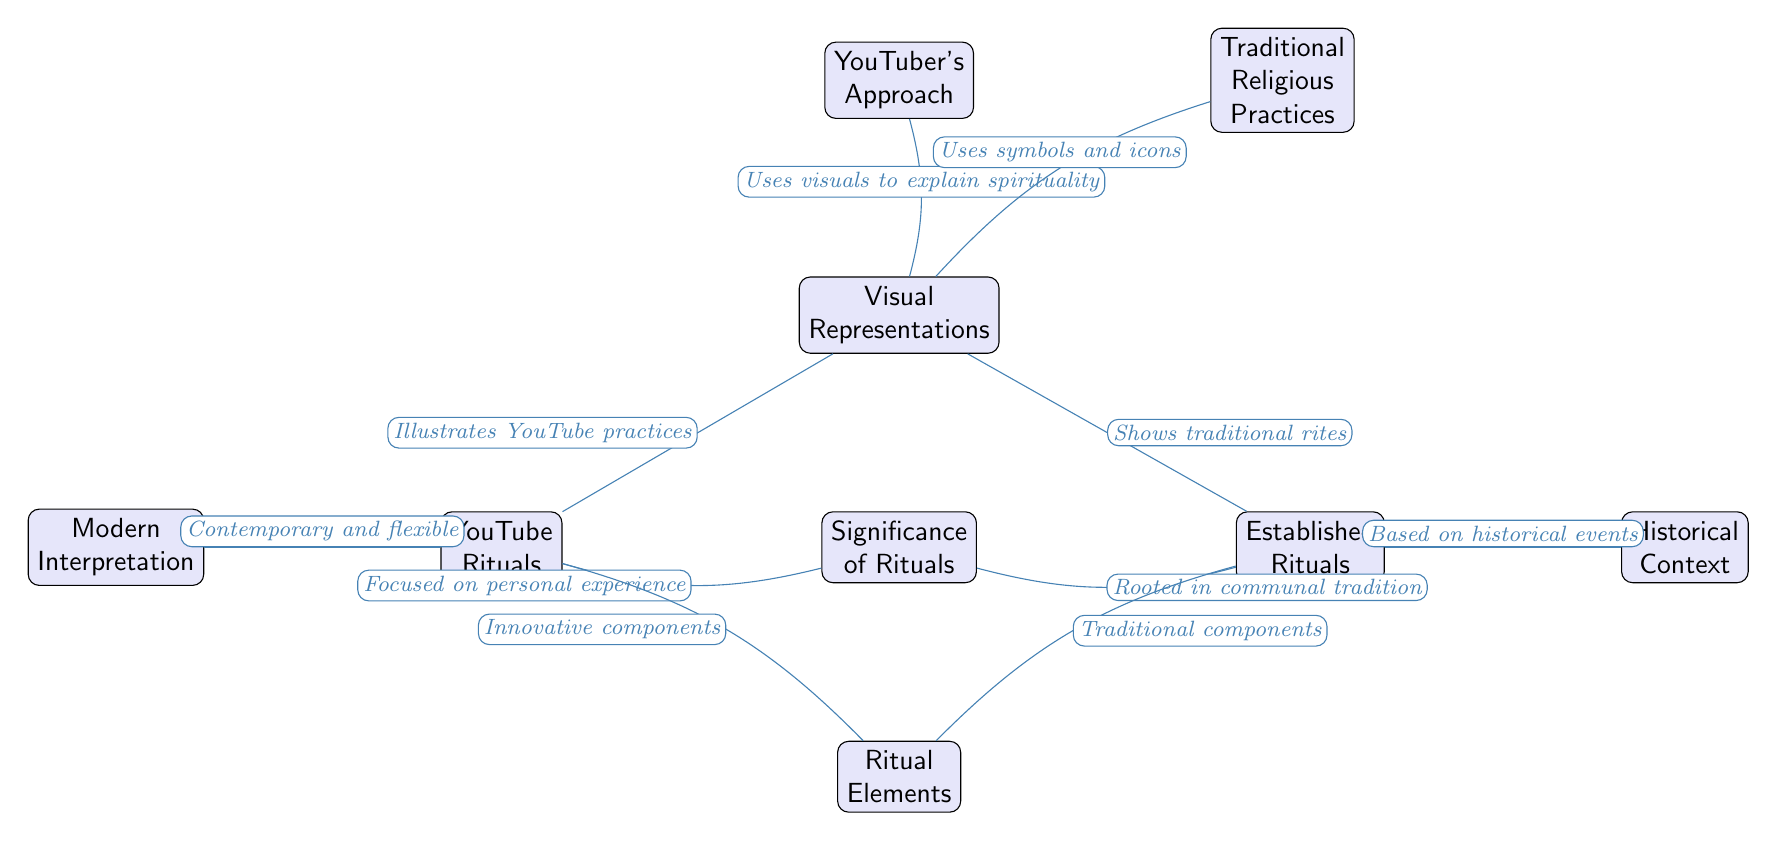what is the primary focus of the YouTuber's approach? The diagram shows that the YouTuber's approach is primarily focused on personal experience, as indicated by the arrow from "YouTube Rituals" to "Significance of Rituals."
Answer: personal experience how many nodes are in the diagram? By counting, there are a total of ten nodes represented in the diagram, including the main node and its connections.
Answer: 10 which node connects to both "YouTube Rituals" and "Significance of Rituals"? The node "Visual Representations" has arrows pointing towards both "YouTube Rituals" and "Significance of Rituals," indicating its central role.
Answer: Visual Representations what is used to explain spirituality in the YouTuber's approach? The arrow from "YouTuber's Approach" to "Visual Representations" states that the YouTuber uses visuals to explain spirituality.
Answer: visuals how do established rituals relate to the significance of rituals? The diagram shows a direct connection from "Established Rituals" to "Significance of Rituals," with the label indicating that established rituals are rooted in communal tradition.
Answer: rooted in communal tradition what elements do both YouTube and established rituals share? According to the diagram, both YouTube Rituals and Established Rituals involve components, where "Innovative components" link to YouTube and "Traditional components" link to established rituals.
Answer: components which aspect of rituals is highlighted by the "Modern Interpretation" node? The diagram indicates that "Modern Interpretation" showcases that YouTube rituals are contemporary and flexible, as described by the label on the connecting edge.
Answer: contemporary and flexible which node represents the historical context of established rituals? The node labeled "Historical Context" connects with the established rituals, as noted by the directed edge that describes its basis on historical events.
Answer: Historical Context 